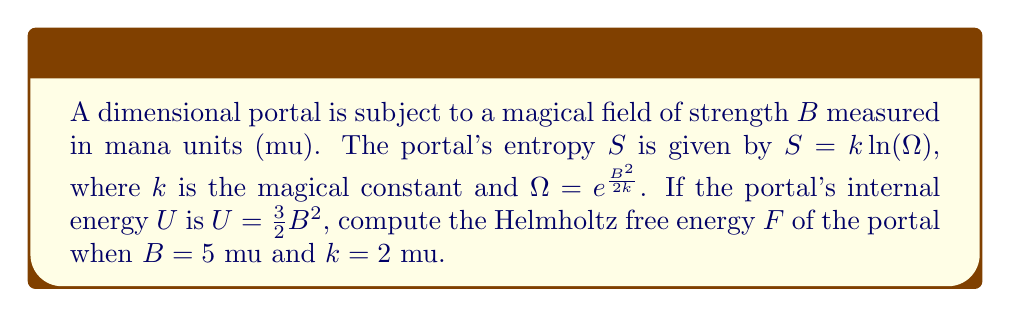What is the answer to this math problem? To solve this problem, we'll follow these steps:

1) Recall the formula for Helmholtz free energy:
   $$F = U - TS$$

2) We're given $U = \frac{3}{2}B^2$. With $B = 5$ mu:
   $$U = \frac{3}{2}(5^2) = \frac{3}{2}(25) = 37.5 \text{ mu}$$

3) For entropy, we need to calculate $\Omega$ first:
   $$\Omega = e^{\frac{B^2}{2k}} = e^{\frac{5^2}{2(2)}} = e^{\frac{25}{4}} \approx 530.516$$

4) Now we can calculate entropy:
   $$S = k \ln(\Omega) = 2 \ln(530.516) \approx 12.538 \text{ mu}$$

5) In statistical mechanics, temperature $T$ is usually defined as $\frac{\partial U}{\partial S}$. Here, we can derive it from the given equations:
   $$T = \frac{\partial U}{\partial S} = \frac{\partial (\frac{3}{2}B^2)}{\partial (k \ln(e^{\frac{B^2}{2k}}))} = \frac{3B}{2k} = \frac{3(5)}{2(2)} = 3.75 \text{ mu}$$

6) Now we have all components to calculate Helmholtz free energy:
   $$F = U - TS = 37.5 - (3.75)(12.538) \approx -9.517 \text{ mu}$$
Answer: $-9.517 \text{ mu}$ 